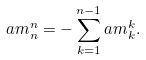<formula> <loc_0><loc_0><loc_500><loc_500>\L a m ^ { n } _ { n } = - \sum _ { k = 1 } ^ { n - 1 } \L a m ^ { k } _ { k } .</formula> 